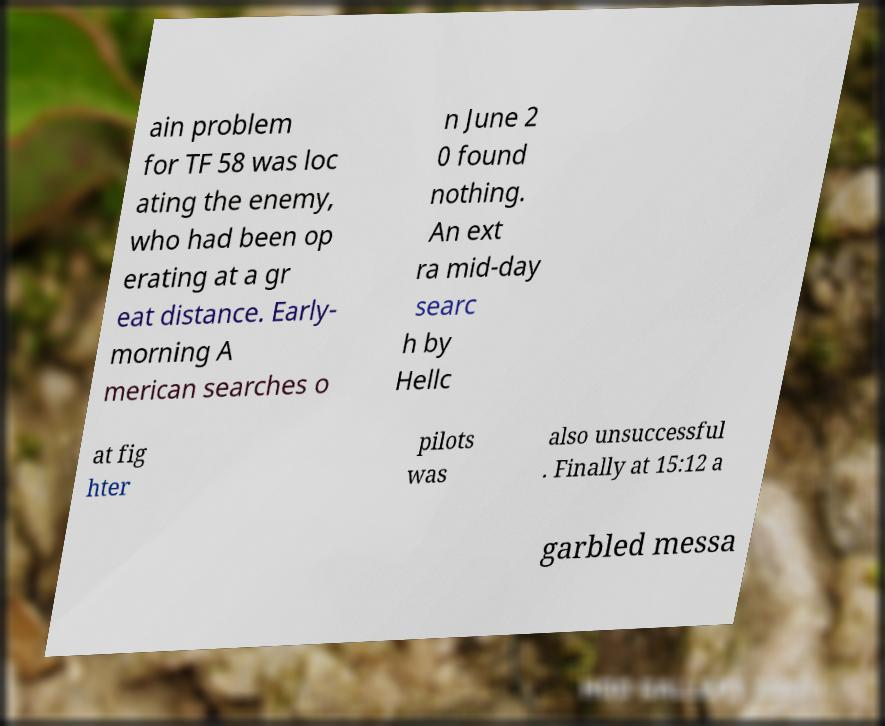Could you extract and type out the text from this image? ain problem for TF 58 was loc ating the enemy, who had been op erating at a gr eat distance. Early- morning A merican searches o n June 2 0 found nothing. An ext ra mid-day searc h by Hellc at fig hter pilots was also unsuccessful . Finally at 15:12 a garbled messa 